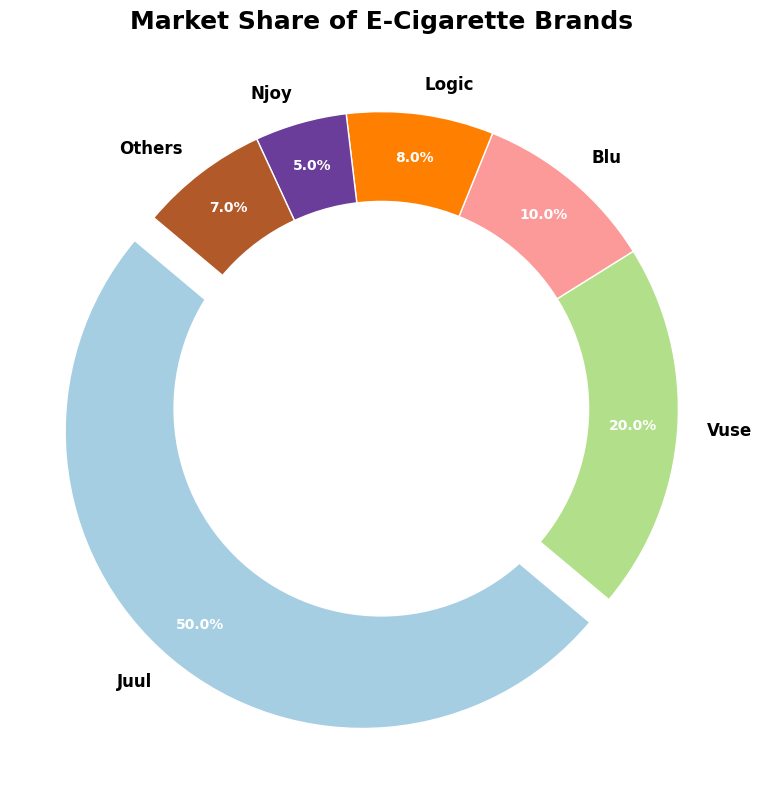Which brand has the highest market share? Juul has the highest market share, as indicated by the largest segment of the pie chart and the percentage value shown near it being 50%.
Answer: Juul What is the combined market share of Logic and Njoy? To find the combined market share, you add the individual market shares of Logic (8%) and Njoy (5%). So, 8% + 5% = 13%.
Answer: 13% How much larger is Juul's market share compared to Blu's? To find how much larger Juul's market share is compared to Blu, subtract Blu's market share from Juul's. So, 50% - 10% = 40%.
Answer: 40% Which brand has the smallest market share? Njoy has the smallest market share, visible as the smallest segment of the pie chart labeled with 5%.
Answer: Njoy What is the total market share of brands other than Juul? To find the market share of brands other than Juul, subtract Juul's market share (50%) from 100%. So, 100% - 50% = 50%.
Answer: 50% What is the difference in market share between Vuse and Others? To find the difference in market share, subtract the market share of Others from Vuse's market share. So, 20% - 7% = 13%.
Answer: 13% Which segment color represents Vuse in the pie chart? Vuse is represented by a segment colored blue in the pie chart, matching the differentiated color associated with each segment.
Answer: Blue If Juul's market share were to drop by 10 percentage points, what would be its new market share percentage? If Juul's market share were to drop by 10 percentage points, subtract 10 from 50. So, 50% - 10% = 40%.
Answer: 40% What percentage of the market is made up by Blu and Logic combined? Add the market shares of Blu (10%) and Logic (8%). So, 10% + 8% = 18%.
Answer: 18% Out of the total market share, which two brands have the closest market shares, and what are their percentages? Comparing the percentages, Logic (8%) and Others (7%) have the closest market shares, differing by only 1%.
Answer: Logic (8%) and Others (7%) 